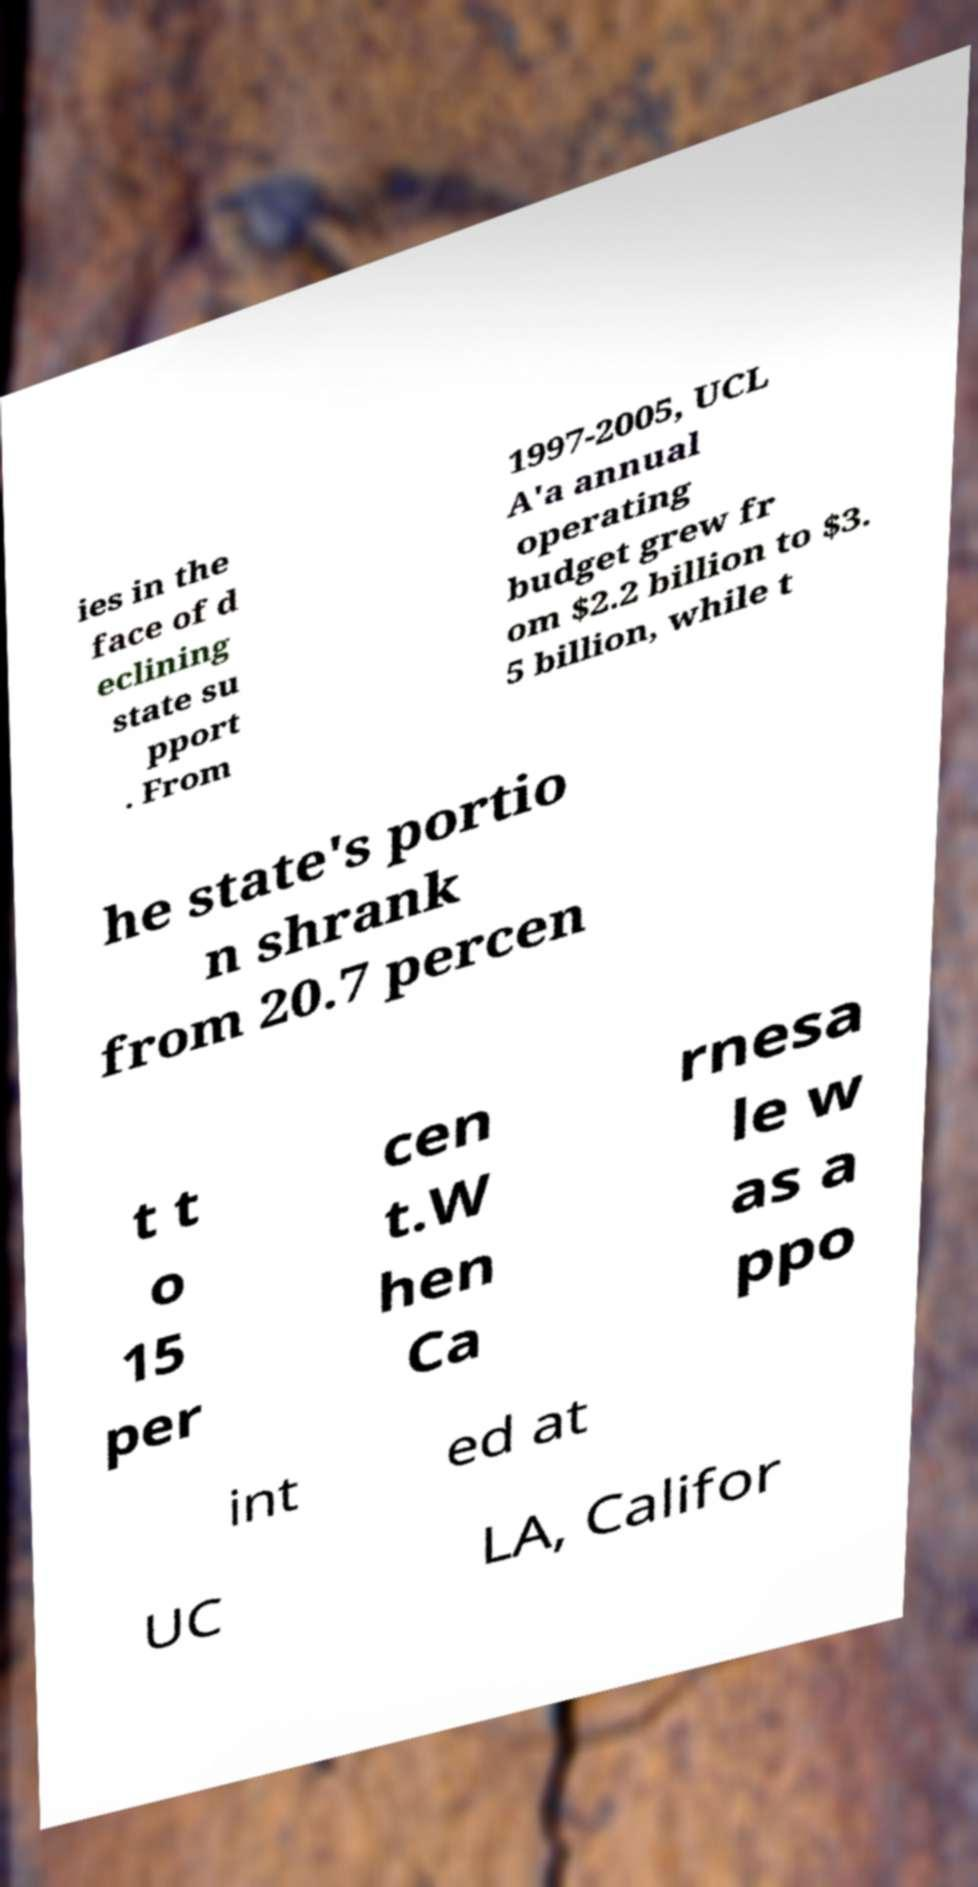Could you assist in decoding the text presented in this image and type it out clearly? ies in the face of d eclining state su pport . From 1997-2005, UCL A'a annual operating budget grew fr om $2.2 billion to $3. 5 billion, while t he state's portio n shrank from 20.7 percen t t o 15 per cen t.W hen Ca rnesa le w as a ppo int ed at UC LA, Califor 